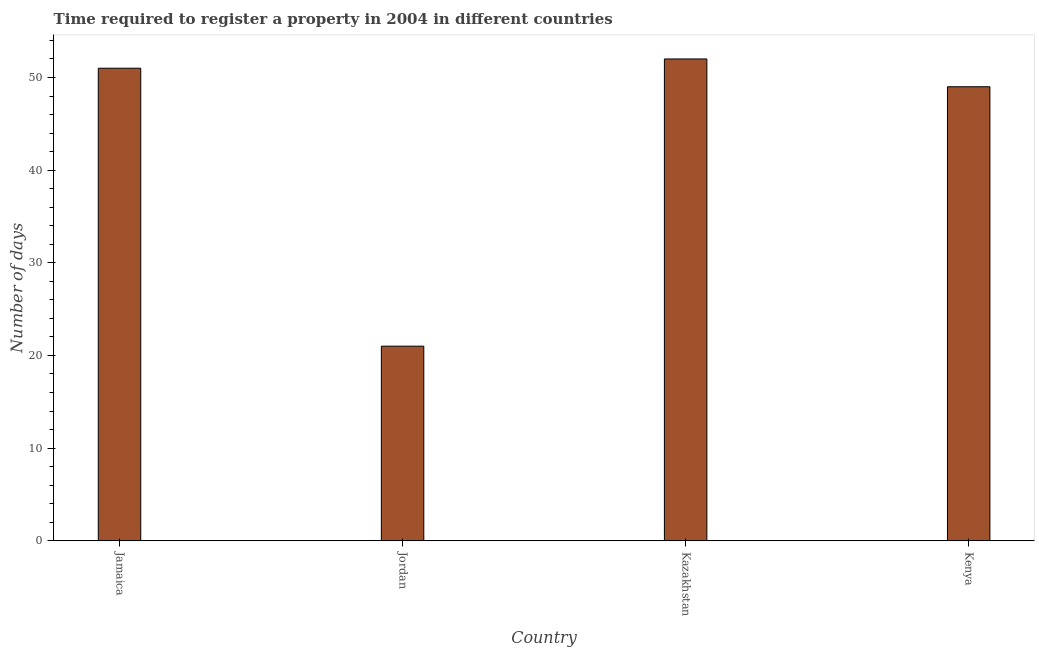What is the title of the graph?
Ensure brevity in your answer.  Time required to register a property in 2004 in different countries. What is the label or title of the X-axis?
Provide a short and direct response. Country. What is the label or title of the Y-axis?
Keep it short and to the point. Number of days. What is the number of days required to register property in Kenya?
Your answer should be compact. 49. Across all countries, what is the maximum number of days required to register property?
Give a very brief answer. 52. In which country was the number of days required to register property maximum?
Provide a short and direct response. Kazakhstan. In which country was the number of days required to register property minimum?
Your response must be concise. Jordan. What is the sum of the number of days required to register property?
Provide a short and direct response. 173. What is the difference between the number of days required to register property in Kazakhstan and Kenya?
Your answer should be very brief. 3. What is the average number of days required to register property per country?
Provide a succinct answer. 43.25. What is the median number of days required to register property?
Offer a terse response. 50. In how many countries, is the number of days required to register property greater than 46 days?
Keep it short and to the point. 3. What is the ratio of the number of days required to register property in Jordan to that in Kenya?
Make the answer very short. 0.43. What is the difference between the highest and the second highest number of days required to register property?
Give a very brief answer. 1. Is the sum of the number of days required to register property in Jordan and Kazakhstan greater than the maximum number of days required to register property across all countries?
Provide a succinct answer. Yes. What is the difference between the highest and the lowest number of days required to register property?
Give a very brief answer. 31. In how many countries, is the number of days required to register property greater than the average number of days required to register property taken over all countries?
Give a very brief answer. 3. Are all the bars in the graph horizontal?
Make the answer very short. No. How many countries are there in the graph?
Your answer should be very brief. 4. What is the Number of days in Jamaica?
Make the answer very short. 51. What is the Number of days of Jordan?
Your answer should be very brief. 21. What is the difference between the Number of days in Jamaica and Jordan?
Offer a very short reply. 30. What is the difference between the Number of days in Jamaica and Kazakhstan?
Ensure brevity in your answer.  -1. What is the difference between the Number of days in Jamaica and Kenya?
Your answer should be very brief. 2. What is the difference between the Number of days in Jordan and Kazakhstan?
Provide a succinct answer. -31. What is the difference between the Number of days in Jordan and Kenya?
Give a very brief answer. -28. What is the difference between the Number of days in Kazakhstan and Kenya?
Your answer should be compact. 3. What is the ratio of the Number of days in Jamaica to that in Jordan?
Offer a terse response. 2.43. What is the ratio of the Number of days in Jamaica to that in Kenya?
Your answer should be very brief. 1.04. What is the ratio of the Number of days in Jordan to that in Kazakhstan?
Offer a very short reply. 0.4. What is the ratio of the Number of days in Jordan to that in Kenya?
Offer a very short reply. 0.43. What is the ratio of the Number of days in Kazakhstan to that in Kenya?
Your response must be concise. 1.06. 